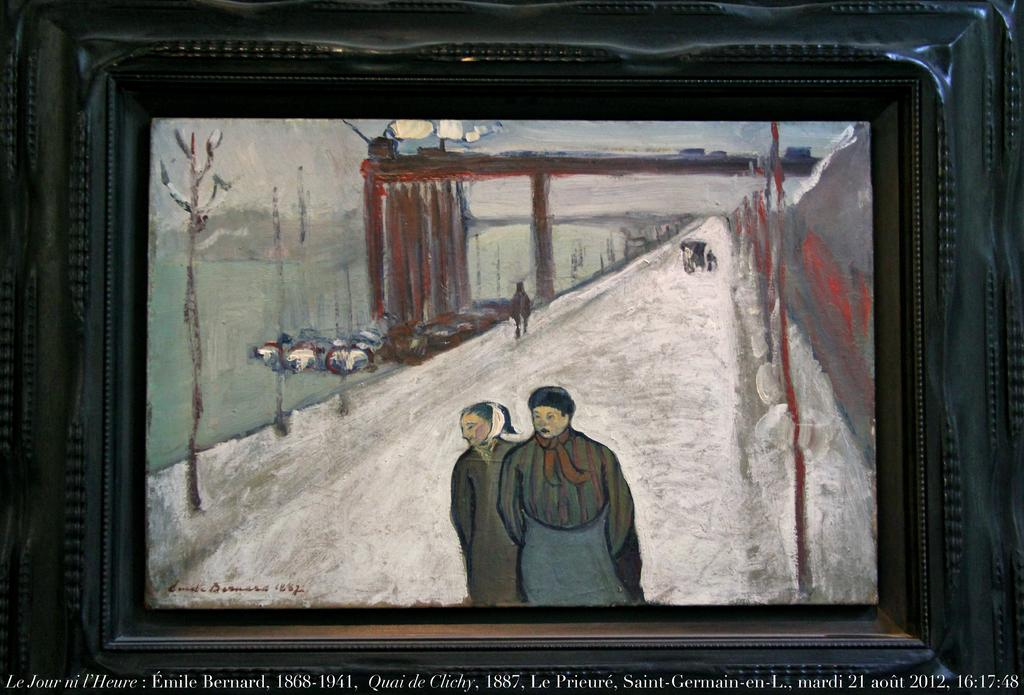<image>
Share a concise interpretation of the image provided. A painting which shows two people in the snow was created by Emile Bernard. 